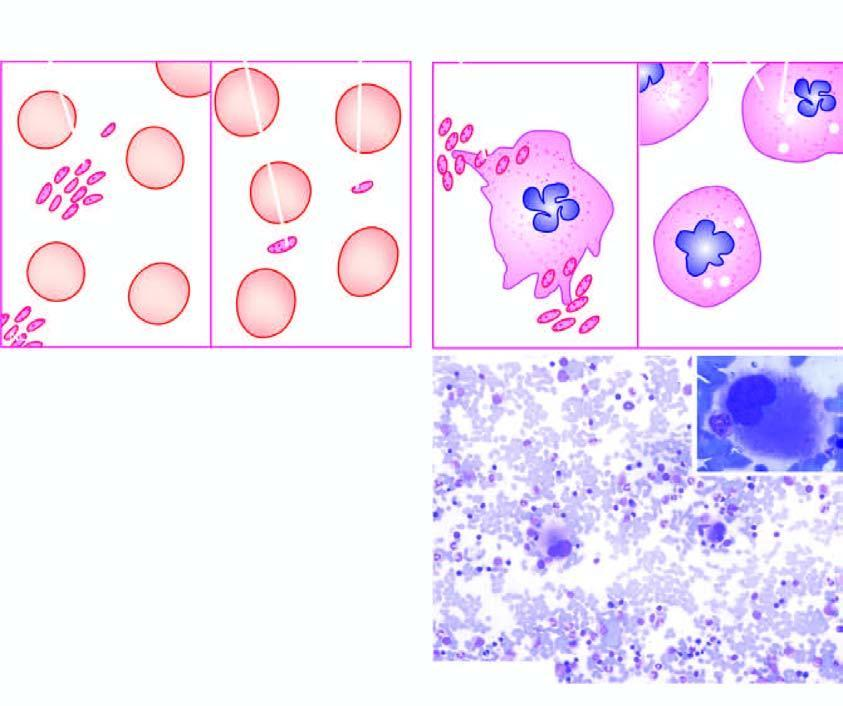what is contrasted with those found in a normal individual?
Answer the question using a single word or phrase. Laboratory findings of itp individual 